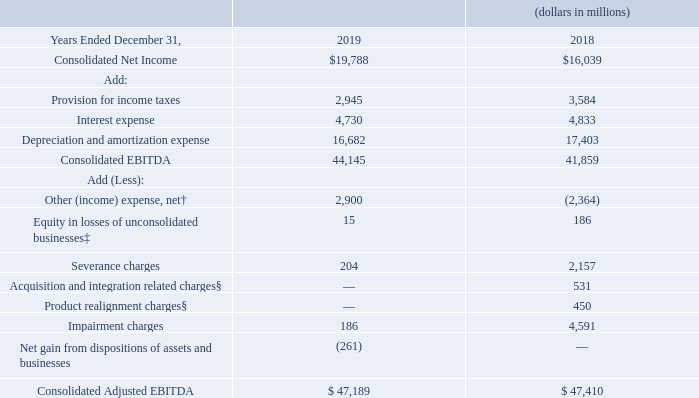Consolidated Net Income, Consolidated EBITDA and Consolidated Adjusted EBITDA
Consolidated earnings before interest, taxes, depreciation and amortization expenses (Consolidated EBITDA) and Consolidated Adjusted EBITDA, which are presented below, are non-generally accepted accounting principles (GAAP) measures that we believe are useful to management, investors and other users of our financial information in evaluating operating profitability on a more variable cost basis as they exclude the depreciation and amortization expense related primarily to capital expenditures and acquisitions that occurred in prior years,
as well as in evaluating operating performance in relation to Verizon’s competitors. Consolidated EBITDA is calculated by adding back interest, taxes, and depreciation and amortization expenses to net income.
Consolidated Adjusted EBITDA is calculated by excluding from Consolidated EBITDA the effect of the following non-operational items: equity in losses of unconsolidated businesses and other income and expense, net, as well as the effect of special items. We believe that this measure is useful to management, investors and other users of our financial information in evaluating the effectiveness of our operations and underlying business trends in a manner that is consistent with management’s evaluation of business performance.
We believe that Consolidated Adjusted EBITDA is widely used by investors to compare a company’s operating performance to its competitors by minimizing impacts caused by differences in capital structure, taxes and depreciation policies. Further, the exclusion of non-operational items and special items enables comparability to prior period performance and trend analysis. See “Special Items” for additional information.
It is management’s intent to provide non-GAAP financial information to enhance the understanding of Verizon’s GAAP financial information, and it should be considered by the reader in addition to, but not instead of, the financial statements prepared in accordance with GAAP. Each non-GAAP financial measure is presented along with the corresponding GAAP measure so as not to imply that more emphasis should be placed on the non-GAAP measure.
We believe that non-GAAP measures provide relevant and useful information, which is used by management, investors and other users of our financial information, as well as by our management in assessing both consolidated and segment performance. The non-GAAP financial information presented may be determined or calculated differently by other companies and may not be directly comparable to that of other companies.
† Includes Pension and benefits mark-to-market adjustments and early debt redemption costs, where applicable. ‡ Includes Product realignment charges and impairment charges, where applicable. § Excludes depreciation and amortization expense.
The changes in Consolidated Net Income, Consolidated EBITDA and Consolidated Adjusted EBITDA in the table above were primarily a result of the factors described in connection with operating revenues and operating expenses.
How is Consolidated Adjusted EBITDA calculated? By excluding from consolidated ebitda the effect of the following non-operational items: equity in losses of unconsolidated businesses and other income and expense, net, as well as the effect of special items. Why is Consolidated Adjusted EBITDA useful? Evaluating the effectiveness of our operations and underlying business trends in a manner that is consistent with management’s evaluation of business performance. What is the Consolidated Net Income in 2019?
Answer scale should be: million. $19,788. What is the change in Consolidated Net Income from 2018 to 2019?
Answer scale should be: million. 19,788-16,039
Answer: 3749. What is the change in Consolidated EBITDA from 2018 to 2019?
Answer scale should be: million. 44,145-41,859
Answer: 2286. What is the change in Consolidated Adjusted EBITDA from 2018 to 2019?
Answer scale should be: million. 47,189-47,410
Answer: -221. 